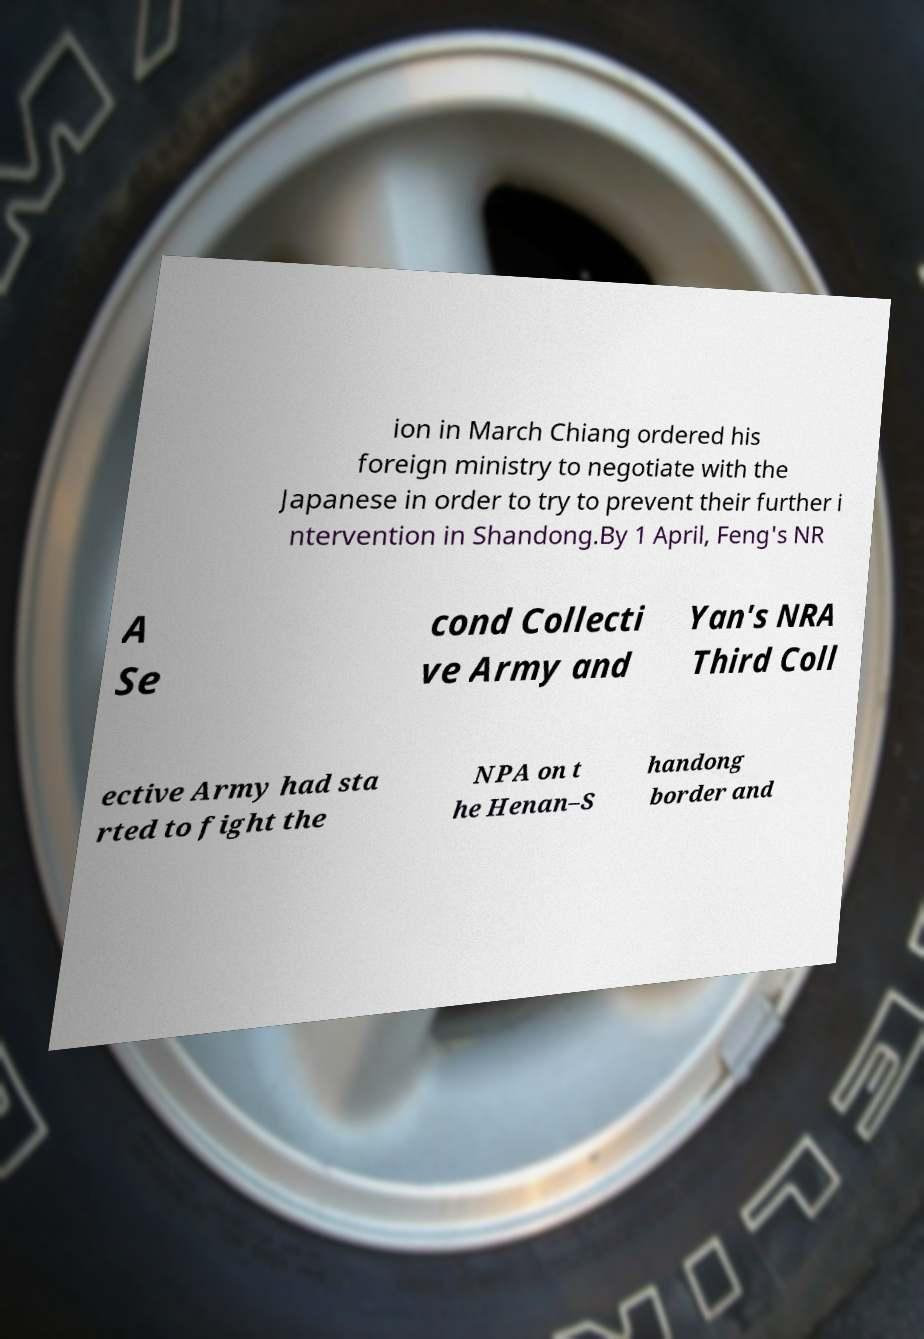Could you extract and type out the text from this image? ion in March Chiang ordered his foreign ministry to negotiate with the Japanese in order to try to prevent their further i ntervention in Shandong.By 1 April, Feng's NR A Se cond Collecti ve Army and Yan's NRA Third Coll ective Army had sta rted to fight the NPA on t he Henan–S handong border and 